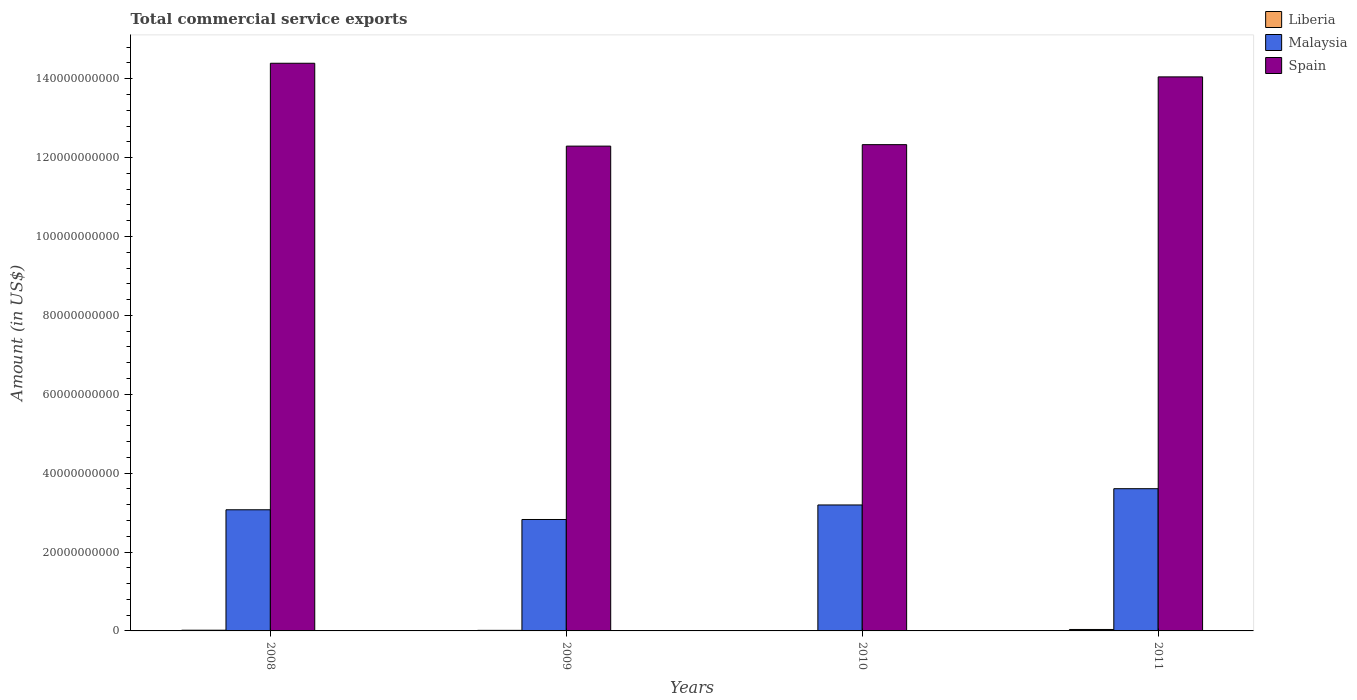Are the number of bars per tick equal to the number of legend labels?
Provide a short and direct response. Yes. What is the label of the 4th group of bars from the left?
Keep it short and to the point. 2011. What is the total commercial service exports in Malaysia in 2010?
Keep it short and to the point. 3.19e+1. Across all years, what is the maximum total commercial service exports in Liberia?
Your answer should be very brief. 3.65e+08. Across all years, what is the minimum total commercial service exports in Spain?
Your response must be concise. 1.23e+11. In which year was the total commercial service exports in Malaysia maximum?
Make the answer very short. 2011. What is the total total commercial service exports in Liberia in the graph?
Make the answer very short. 7.29e+08. What is the difference between the total commercial service exports in Malaysia in 2009 and that in 2011?
Offer a very short reply. -7.80e+09. What is the difference between the total commercial service exports in Spain in 2008 and the total commercial service exports in Liberia in 2011?
Make the answer very short. 1.44e+11. What is the average total commercial service exports in Malaysia per year?
Your answer should be compact. 3.17e+1. In the year 2010, what is the difference between the total commercial service exports in Liberia and total commercial service exports in Malaysia?
Offer a very short reply. -3.19e+1. In how many years, is the total commercial service exports in Spain greater than 104000000000 US$?
Offer a terse response. 4. What is the ratio of the total commercial service exports in Spain in 2009 to that in 2010?
Your response must be concise. 1. Is the total commercial service exports in Spain in 2010 less than that in 2011?
Make the answer very short. Yes. Is the difference between the total commercial service exports in Liberia in 2009 and 2010 greater than the difference between the total commercial service exports in Malaysia in 2009 and 2010?
Your answer should be very brief. Yes. What is the difference between the highest and the second highest total commercial service exports in Spain?
Your response must be concise. 3.45e+09. What is the difference between the highest and the lowest total commercial service exports in Spain?
Keep it short and to the point. 2.10e+1. Is the sum of the total commercial service exports in Liberia in 2010 and 2011 greater than the maximum total commercial service exports in Spain across all years?
Provide a short and direct response. No. What does the 3rd bar from the left in 2008 represents?
Ensure brevity in your answer.  Spain. What does the 1st bar from the right in 2011 represents?
Offer a terse response. Spain. How many bars are there?
Provide a succinct answer. 12. Are all the bars in the graph horizontal?
Make the answer very short. No. How many years are there in the graph?
Your answer should be very brief. 4. What is the difference between two consecutive major ticks on the Y-axis?
Ensure brevity in your answer.  2.00e+1. Does the graph contain grids?
Provide a short and direct response. No. Where does the legend appear in the graph?
Your answer should be very brief. Top right. How many legend labels are there?
Your answer should be very brief. 3. How are the legend labels stacked?
Keep it short and to the point. Vertical. What is the title of the graph?
Your answer should be very brief. Total commercial service exports. What is the Amount (in US$) of Liberia in 2008?
Provide a short and direct response. 1.82e+08. What is the Amount (in US$) in Malaysia in 2008?
Offer a very short reply. 3.07e+1. What is the Amount (in US$) in Spain in 2008?
Your answer should be very brief. 1.44e+11. What is the Amount (in US$) of Liberia in 2009?
Your response must be concise. 1.42e+08. What is the Amount (in US$) in Malaysia in 2009?
Ensure brevity in your answer.  2.82e+1. What is the Amount (in US$) of Spain in 2009?
Make the answer very short. 1.23e+11. What is the Amount (in US$) of Liberia in 2010?
Give a very brief answer. 3.98e+07. What is the Amount (in US$) in Malaysia in 2010?
Make the answer very short. 3.19e+1. What is the Amount (in US$) of Spain in 2010?
Make the answer very short. 1.23e+11. What is the Amount (in US$) of Liberia in 2011?
Your answer should be compact. 3.65e+08. What is the Amount (in US$) of Malaysia in 2011?
Make the answer very short. 3.61e+1. What is the Amount (in US$) of Spain in 2011?
Offer a terse response. 1.40e+11. Across all years, what is the maximum Amount (in US$) in Liberia?
Ensure brevity in your answer.  3.65e+08. Across all years, what is the maximum Amount (in US$) of Malaysia?
Make the answer very short. 3.61e+1. Across all years, what is the maximum Amount (in US$) in Spain?
Your answer should be compact. 1.44e+11. Across all years, what is the minimum Amount (in US$) of Liberia?
Make the answer very short. 3.98e+07. Across all years, what is the minimum Amount (in US$) of Malaysia?
Provide a short and direct response. 2.82e+1. Across all years, what is the minimum Amount (in US$) in Spain?
Provide a succinct answer. 1.23e+11. What is the total Amount (in US$) of Liberia in the graph?
Your response must be concise. 7.29e+08. What is the total Amount (in US$) in Malaysia in the graph?
Make the answer very short. 1.27e+11. What is the total Amount (in US$) in Spain in the graph?
Keep it short and to the point. 5.31e+11. What is the difference between the Amount (in US$) in Liberia in 2008 and that in 2009?
Ensure brevity in your answer.  3.93e+07. What is the difference between the Amount (in US$) of Malaysia in 2008 and that in 2009?
Give a very brief answer. 2.46e+09. What is the difference between the Amount (in US$) in Spain in 2008 and that in 2009?
Your answer should be compact. 2.10e+1. What is the difference between the Amount (in US$) in Liberia in 2008 and that in 2010?
Ensure brevity in your answer.  1.42e+08. What is the difference between the Amount (in US$) in Malaysia in 2008 and that in 2010?
Provide a succinct answer. -1.22e+09. What is the difference between the Amount (in US$) of Spain in 2008 and that in 2010?
Keep it short and to the point. 2.06e+1. What is the difference between the Amount (in US$) of Liberia in 2008 and that in 2011?
Provide a succinct answer. -1.84e+08. What is the difference between the Amount (in US$) in Malaysia in 2008 and that in 2011?
Provide a succinct answer. -5.34e+09. What is the difference between the Amount (in US$) in Spain in 2008 and that in 2011?
Your answer should be very brief. 3.45e+09. What is the difference between the Amount (in US$) in Liberia in 2009 and that in 2010?
Your answer should be very brief. 1.03e+08. What is the difference between the Amount (in US$) of Malaysia in 2009 and that in 2010?
Offer a terse response. -3.68e+09. What is the difference between the Amount (in US$) in Spain in 2009 and that in 2010?
Keep it short and to the point. -3.70e+08. What is the difference between the Amount (in US$) in Liberia in 2009 and that in 2011?
Offer a very short reply. -2.23e+08. What is the difference between the Amount (in US$) in Malaysia in 2009 and that in 2011?
Your answer should be very brief. -7.80e+09. What is the difference between the Amount (in US$) in Spain in 2009 and that in 2011?
Provide a short and direct response. -1.76e+1. What is the difference between the Amount (in US$) of Liberia in 2010 and that in 2011?
Your answer should be very brief. -3.26e+08. What is the difference between the Amount (in US$) of Malaysia in 2010 and that in 2011?
Offer a very short reply. -4.12e+09. What is the difference between the Amount (in US$) of Spain in 2010 and that in 2011?
Your answer should be compact. -1.72e+1. What is the difference between the Amount (in US$) of Liberia in 2008 and the Amount (in US$) of Malaysia in 2009?
Offer a very short reply. -2.81e+1. What is the difference between the Amount (in US$) of Liberia in 2008 and the Amount (in US$) of Spain in 2009?
Provide a succinct answer. -1.23e+11. What is the difference between the Amount (in US$) of Malaysia in 2008 and the Amount (in US$) of Spain in 2009?
Keep it short and to the point. -9.22e+1. What is the difference between the Amount (in US$) of Liberia in 2008 and the Amount (in US$) of Malaysia in 2010?
Offer a terse response. -3.18e+1. What is the difference between the Amount (in US$) of Liberia in 2008 and the Amount (in US$) of Spain in 2010?
Provide a short and direct response. -1.23e+11. What is the difference between the Amount (in US$) in Malaysia in 2008 and the Amount (in US$) in Spain in 2010?
Offer a very short reply. -9.26e+1. What is the difference between the Amount (in US$) of Liberia in 2008 and the Amount (in US$) of Malaysia in 2011?
Your answer should be compact. -3.59e+1. What is the difference between the Amount (in US$) of Liberia in 2008 and the Amount (in US$) of Spain in 2011?
Your answer should be compact. -1.40e+11. What is the difference between the Amount (in US$) of Malaysia in 2008 and the Amount (in US$) of Spain in 2011?
Give a very brief answer. -1.10e+11. What is the difference between the Amount (in US$) in Liberia in 2009 and the Amount (in US$) in Malaysia in 2010?
Give a very brief answer. -3.18e+1. What is the difference between the Amount (in US$) in Liberia in 2009 and the Amount (in US$) in Spain in 2010?
Your answer should be compact. -1.23e+11. What is the difference between the Amount (in US$) in Malaysia in 2009 and the Amount (in US$) in Spain in 2010?
Provide a short and direct response. -9.50e+1. What is the difference between the Amount (in US$) of Liberia in 2009 and the Amount (in US$) of Malaysia in 2011?
Offer a terse response. -3.59e+1. What is the difference between the Amount (in US$) of Liberia in 2009 and the Amount (in US$) of Spain in 2011?
Your answer should be compact. -1.40e+11. What is the difference between the Amount (in US$) of Malaysia in 2009 and the Amount (in US$) of Spain in 2011?
Your response must be concise. -1.12e+11. What is the difference between the Amount (in US$) in Liberia in 2010 and the Amount (in US$) in Malaysia in 2011?
Give a very brief answer. -3.60e+1. What is the difference between the Amount (in US$) in Liberia in 2010 and the Amount (in US$) in Spain in 2011?
Provide a succinct answer. -1.40e+11. What is the difference between the Amount (in US$) in Malaysia in 2010 and the Amount (in US$) in Spain in 2011?
Provide a short and direct response. -1.09e+11. What is the average Amount (in US$) in Liberia per year?
Offer a very short reply. 1.82e+08. What is the average Amount (in US$) of Malaysia per year?
Your answer should be compact. 3.17e+1. What is the average Amount (in US$) of Spain per year?
Make the answer very short. 1.33e+11. In the year 2008, what is the difference between the Amount (in US$) in Liberia and Amount (in US$) in Malaysia?
Give a very brief answer. -3.05e+1. In the year 2008, what is the difference between the Amount (in US$) in Liberia and Amount (in US$) in Spain?
Keep it short and to the point. -1.44e+11. In the year 2008, what is the difference between the Amount (in US$) in Malaysia and Amount (in US$) in Spain?
Your answer should be very brief. -1.13e+11. In the year 2009, what is the difference between the Amount (in US$) of Liberia and Amount (in US$) of Malaysia?
Keep it short and to the point. -2.81e+1. In the year 2009, what is the difference between the Amount (in US$) in Liberia and Amount (in US$) in Spain?
Give a very brief answer. -1.23e+11. In the year 2009, what is the difference between the Amount (in US$) in Malaysia and Amount (in US$) in Spain?
Provide a succinct answer. -9.47e+1. In the year 2010, what is the difference between the Amount (in US$) of Liberia and Amount (in US$) of Malaysia?
Your answer should be compact. -3.19e+1. In the year 2010, what is the difference between the Amount (in US$) in Liberia and Amount (in US$) in Spain?
Ensure brevity in your answer.  -1.23e+11. In the year 2010, what is the difference between the Amount (in US$) of Malaysia and Amount (in US$) of Spain?
Your answer should be compact. -9.13e+1. In the year 2011, what is the difference between the Amount (in US$) of Liberia and Amount (in US$) of Malaysia?
Give a very brief answer. -3.57e+1. In the year 2011, what is the difference between the Amount (in US$) of Liberia and Amount (in US$) of Spain?
Your answer should be compact. -1.40e+11. In the year 2011, what is the difference between the Amount (in US$) of Malaysia and Amount (in US$) of Spain?
Keep it short and to the point. -1.04e+11. What is the ratio of the Amount (in US$) in Liberia in 2008 to that in 2009?
Your answer should be very brief. 1.28. What is the ratio of the Amount (in US$) in Malaysia in 2008 to that in 2009?
Make the answer very short. 1.09. What is the ratio of the Amount (in US$) of Spain in 2008 to that in 2009?
Ensure brevity in your answer.  1.17. What is the ratio of the Amount (in US$) of Liberia in 2008 to that in 2010?
Give a very brief answer. 4.57. What is the ratio of the Amount (in US$) of Malaysia in 2008 to that in 2010?
Offer a very short reply. 0.96. What is the ratio of the Amount (in US$) in Spain in 2008 to that in 2010?
Provide a succinct answer. 1.17. What is the ratio of the Amount (in US$) in Liberia in 2008 to that in 2011?
Ensure brevity in your answer.  0.5. What is the ratio of the Amount (in US$) of Malaysia in 2008 to that in 2011?
Offer a very short reply. 0.85. What is the ratio of the Amount (in US$) of Spain in 2008 to that in 2011?
Your answer should be compact. 1.02. What is the ratio of the Amount (in US$) in Liberia in 2009 to that in 2010?
Provide a succinct answer. 3.58. What is the ratio of the Amount (in US$) in Malaysia in 2009 to that in 2010?
Make the answer very short. 0.88. What is the ratio of the Amount (in US$) of Liberia in 2009 to that in 2011?
Offer a very short reply. 0.39. What is the ratio of the Amount (in US$) of Malaysia in 2009 to that in 2011?
Give a very brief answer. 0.78. What is the ratio of the Amount (in US$) in Liberia in 2010 to that in 2011?
Give a very brief answer. 0.11. What is the ratio of the Amount (in US$) in Malaysia in 2010 to that in 2011?
Your response must be concise. 0.89. What is the ratio of the Amount (in US$) of Spain in 2010 to that in 2011?
Provide a succinct answer. 0.88. What is the difference between the highest and the second highest Amount (in US$) of Liberia?
Your answer should be very brief. 1.84e+08. What is the difference between the highest and the second highest Amount (in US$) in Malaysia?
Keep it short and to the point. 4.12e+09. What is the difference between the highest and the second highest Amount (in US$) of Spain?
Your answer should be compact. 3.45e+09. What is the difference between the highest and the lowest Amount (in US$) in Liberia?
Offer a terse response. 3.26e+08. What is the difference between the highest and the lowest Amount (in US$) in Malaysia?
Provide a succinct answer. 7.80e+09. What is the difference between the highest and the lowest Amount (in US$) in Spain?
Offer a terse response. 2.10e+1. 